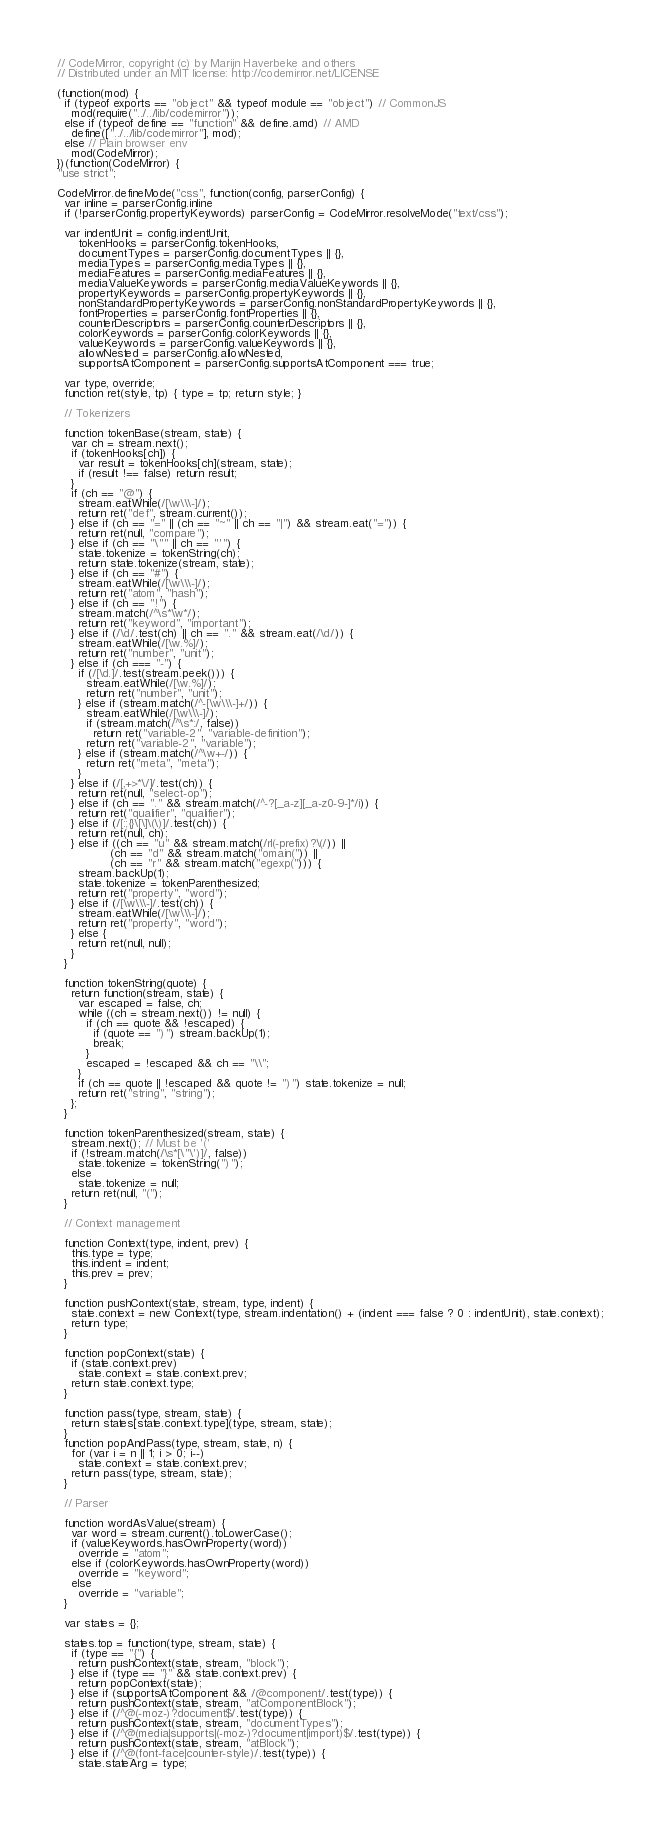<code> <loc_0><loc_0><loc_500><loc_500><_JavaScript_>// CodeMirror, copyright (c) by Marijn Haverbeke and others
// Distributed under an MIT license: http://codemirror.net/LICENSE

(function(mod) {
  if (typeof exports == "object" && typeof module == "object") // CommonJS
    mod(require("../../lib/codemirror"));
  else if (typeof define == "function" && define.amd) // AMD
    define(["../../lib/codemirror"], mod);
  else // Plain browser env
    mod(CodeMirror);
})(function(CodeMirror) {
"use strict";

CodeMirror.defineMode("css", function(config, parserConfig) {
  var inline = parserConfig.inline
  if (!parserConfig.propertyKeywords) parserConfig = CodeMirror.resolveMode("text/css");

  var indentUnit = config.indentUnit,
      tokenHooks = parserConfig.tokenHooks,
      documentTypes = parserConfig.documentTypes || {},
      mediaTypes = parserConfig.mediaTypes || {},
      mediaFeatures = parserConfig.mediaFeatures || {},
      mediaValueKeywords = parserConfig.mediaValueKeywords || {},
      propertyKeywords = parserConfig.propertyKeywords || {},
      nonStandardPropertyKeywords = parserConfig.nonStandardPropertyKeywords || {},
      fontProperties = parserConfig.fontProperties || {},
      counterDescriptors = parserConfig.counterDescriptors || {},
      colorKeywords = parserConfig.colorKeywords || {},
      valueKeywords = parserConfig.valueKeywords || {},
      allowNested = parserConfig.allowNested,
      supportsAtComponent = parserConfig.supportsAtComponent === true;

  var type, override;
  function ret(style, tp) { type = tp; return style; }

  // Tokenizers

  function tokenBase(stream, state) {
    var ch = stream.next();
    if (tokenHooks[ch]) {
      var result = tokenHooks[ch](stream, state);
      if (result !== false) return result;
    }
    if (ch == "@") {
      stream.eatWhile(/[\w\\\-]/);
      return ret("def", stream.current());
    } else if (ch == "=" || (ch == "~" || ch == "|") && stream.eat("=")) {
      return ret(null, "compare");
    } else if (ch == "\"" || ch == "'") {
      state.tokenize = tokenString(ch);
      return state.tokenize(stream, state);
    } else if (ch == "#") {
      stream.eatWhile(/[\w\\\-]/);
      return ret("atom", "hash");
    } else if (ch == "!") {
      stream.match(/^\s*\w*/);
      return ret("keyword", "important");
    } else if (/\d/.test(ch) || ch == "." && stream.eat(/\d/)) {
      stream.eatWhile(/[\w.%]/);
      return ret("number", "unit");
    } else if (ch === "-") {
      if (/[\d.]/.test(stream.peek())) {
        stream.eatWhile(/[\w.%]/);
        return ret("number", "unit");
      } else if (stream.match(/^-[\w\\\-]+/)) {
        stream.eatWhile(/[\w\\\-]/);
        if (stream.match(/^\s*:/, false))
          return ret("variable-2", "variable-definition");
        return ret("variable-2", "variable");
      } else if (stream.match(/^\w+-/)) {
        return ret("meta", "meta");
      }
    } else if (/[,+>*\/]/.test(ch)) {
      return ret(null, "select-op");
    } else if (ch == "." && stream.match(/^-?[_a-z][_a-z0-9-]*/i)) {
      return ret("qualifier", "qualifier");
    } else if (/[:;{}\[\]\(\)]/.test(ch)) {
      return ret(null, ch);
    } else if ((ch == "u" && stream.match(/rl(-prefix)?\(/)) ||
               (ch == "d" && stream.match("omain(")) ||
               (ch == "r" && stream.match("egexp("))) {
      stream.backUp(1);
      state.tokenize = tokenParenthesized;
      return ret("property", "word");
    } else if (/[\w\\\-]/.test(ch)) {
      stream.eatWhile(/[\w\\\-]/);
      return ret("property", "word");
    } else {
      return ret(null, null);
    }
  }

  function tokenString(quote) {
    return function(stream, state) {
      var escaped = false, ch;
      while ((ch = stream.next()) != null) {
        if (ch == quote && !escaped) {
          if (quote == ")") stream.backUp(1);
          break;
        }
        escaped = !escaped && ch == "\\";
      }
      if (ch == quote || !escaped && quote != ")") state.tokenize = null;
      return ret("string", "string");
    };
  }

  function tokenParenthesized(stream, state) {
    stream.next(); // Must be '('
    if (!stream.match(/\s*[\"\')]/, false))
      state.tokenize = tokenString(")");
    else
      state.tokenize = null;
    return ret(null, "(");
  }

  // Context management

  function Context(type, indent, prev) {
    this.type = type;
    this.indent = indent;
    this.prev = prev;
  }

  function pushContext(state, stream, type, indent) {
    state.context = new Context(type, stream.indentation() + (indent === false ? 0 : indentUnit), state.context);
    return type;
  }

  function popContext(state) {
    if (state.context.prev)
      state.context = state.context.prev;
    return state.context.type;
  }

  function pass(type, stream, state) {
    return states[state.context.type](type, stream, state);
  }
  function popAndPass(type, stream, state, n) {
    for (var i = n || 1; i > 0; i--)
      state.context = state.context.prev;
    return pass(type, stream, state);
  }

  // Parser

  function wordAsValue(stream) {
    var word = stream.current().toLowerCase();
    if (valueKeywords.hasOwnProperty(word))
      override = "atom";
    else if (colorKeywords.hasOwnProperty(word))
      override = "keyword";
    else
      override = "variable";
  }

  var states = {};

  states.top = function(type, stream, state) {
    if (type == "{") {
      return pushContext(state, stream, "block");
    } else if (type == "}" && state.context.prev) {
      return popContext(state);
    } else if (supportsAtComponent && /@component/.test(type)) {
      return pushContext(state, stream, "atComponentBlock");
    } else if (/^@(-moz-)?document$/.test(type)) {
      return pushContext(state, stream, "documentTypes");
    } else if (/^@(media|supports|(-moz-)?document|import)$/.test(type)) {
      return pushContext(state, stream, "atBlock");
    } else if (/^@(font-face|counter-style)/.test(type)) {
      state.stateArg = type;</code> 